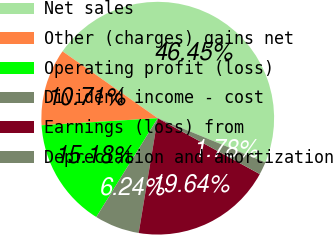Convert chart to OTSL. <chart><loc_0><loc_0><loc_500><loc_500><pie_chart><fcel>Net sales<fcel>Other (charges) gains net<fcel>Operating profit (loss)<fcel>Dividend income - cost<fcel>Earnings (loss) from<fcel>Depreciation and amortization<nl><fcel>46.45%<fcel>10.71%<fcel>15.18%<fcel>6.24%<fcel>19.64%<fcel>1.78%<nl></chart> 